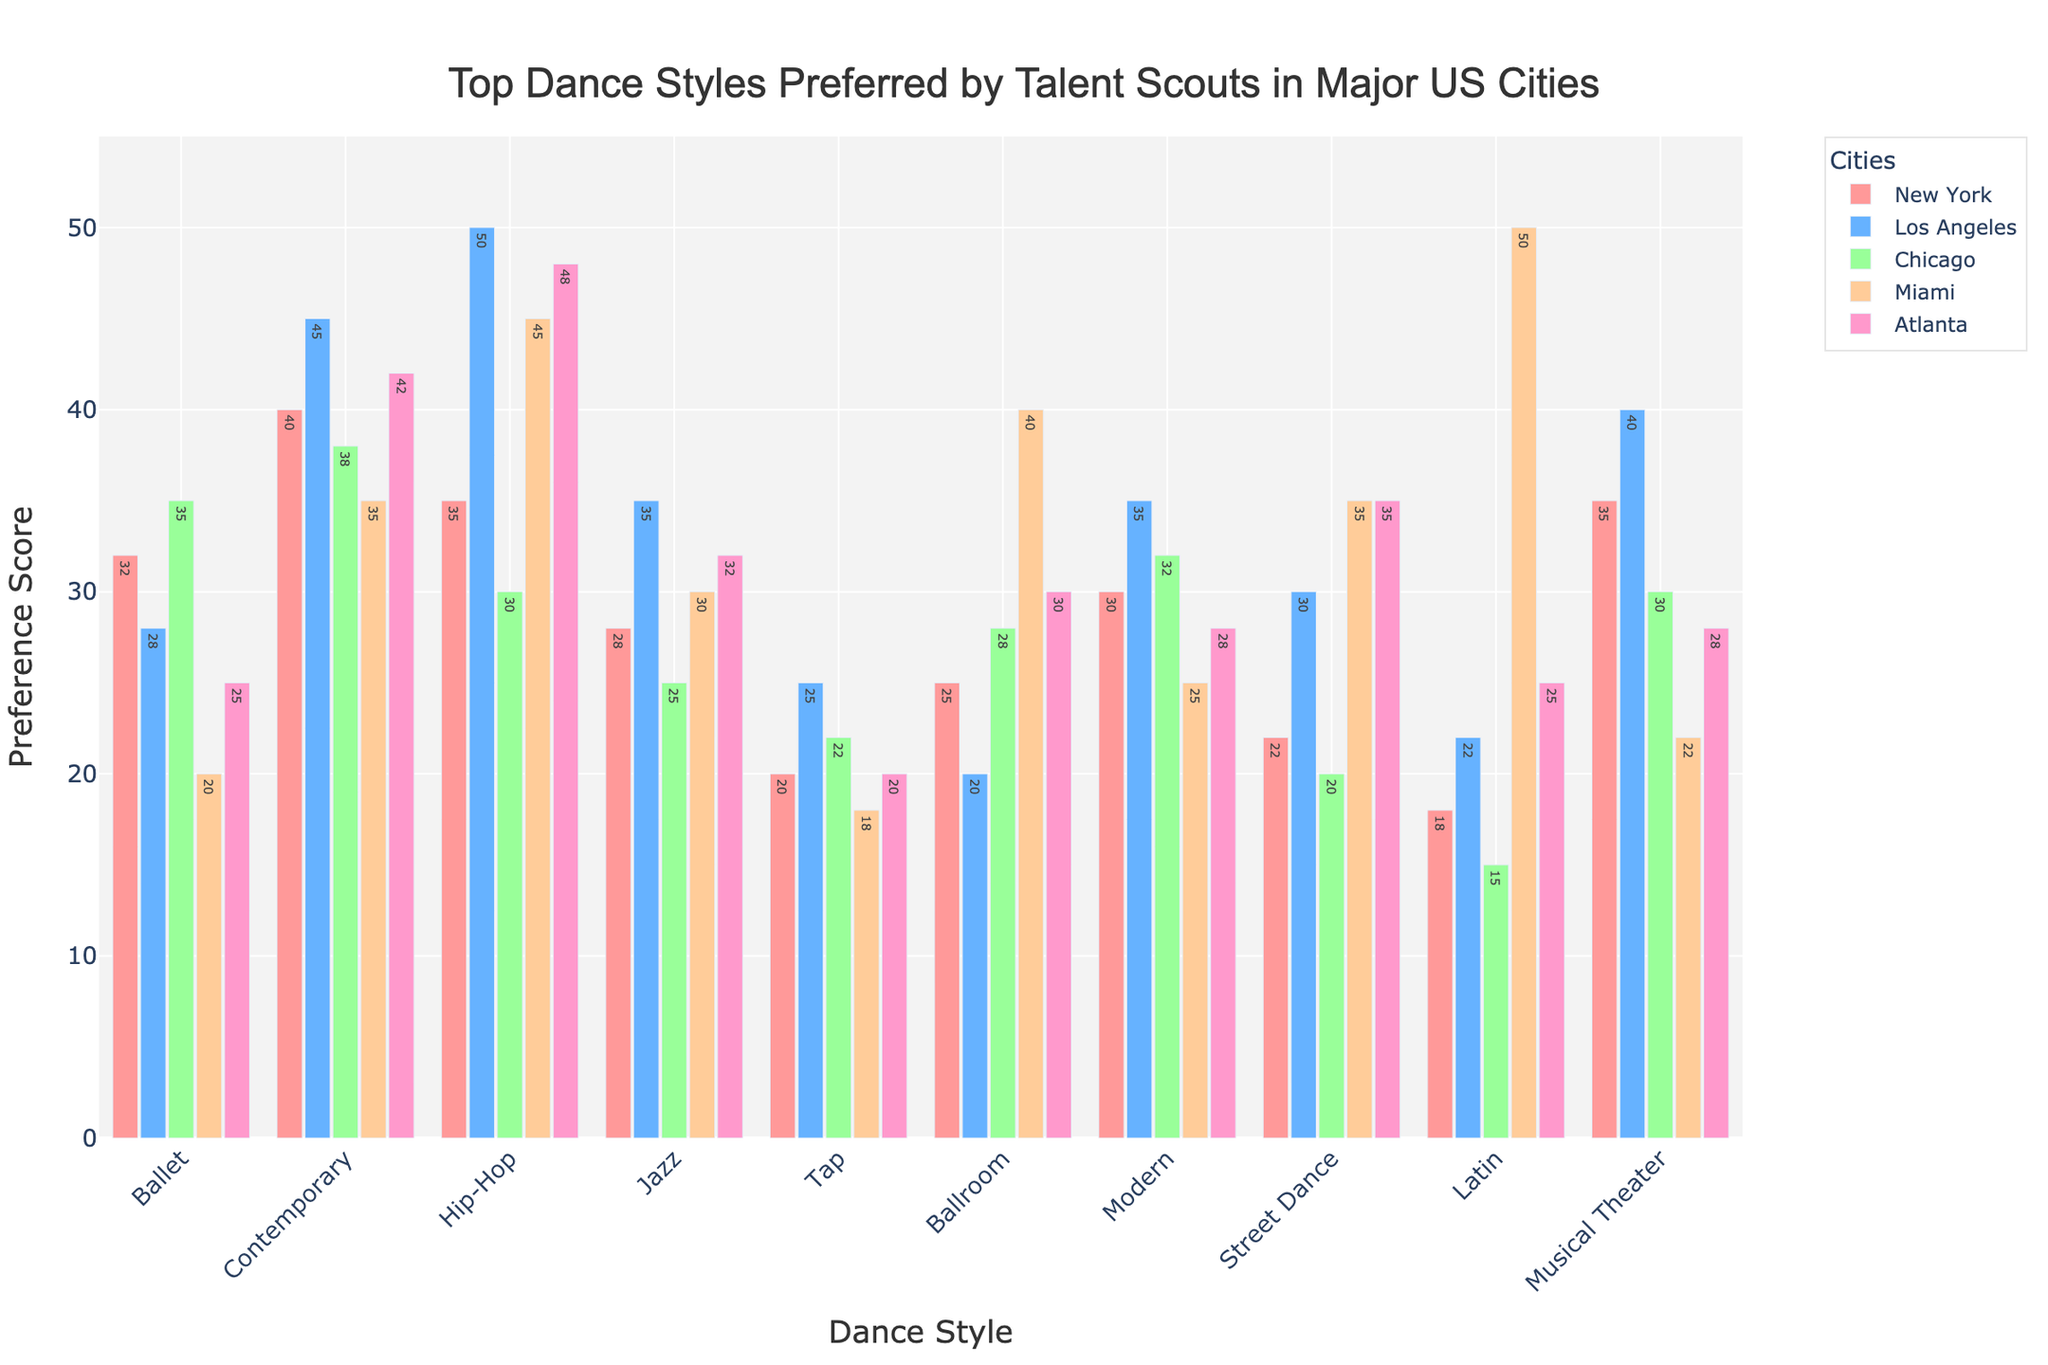What is the most preferred dance style in Los Angeles? To determine the most preferred dance style in Los Angeles, observe the bars corresponding to Los Angeles and identify the highest one. Hip-Hop has the highest bar.
Answer: Hip-Hop Which city has the highest preference score for Latin dance? Look for bars corresponding to Latin dance for each city. Compare their heights and identify the tallest bar. Miami has the highest Latin dance preference score.
Answer: Miami What is the difference in preference scores for Ballet and Hip-Hop in New York? Identify the bars for Ballet and Hip-Hop in New York. Subtract the Ballet score (32) from the Hip-Hop score (35). The difference is 35 - 32 = 3.
Answer: 3 Which dance style has the least preference in Chicago? Locate the bars for Chicago and find the shortest one. The bar for Latin dance is the shortest.
Answer: Latin Is the preference score for Ballroom higher in Miami or Los Angeles? Compare the bars for Ballroom in Miami and Los Angeles. The bar for Miami (40) is higher than for Los Angeles (20).
Answer: Miami What is the average preference score for Contemporary dance across all cities? Sum up the Contemporary scores for all cities (40 + 45 + 38 + 35 + 42 = 200). Divide by the number of cities (5). The average is 200 / 5 = 40.
Answer: 40 Which city has the second-highest preference for Street Dance? Look at the bars for Street Dance in each city. The scores are New York (22), Los Angeles (30), Chicago (20), Miami (35), and Atlanta (35). Both Miami and Atlanta have the highest score (35) but not the second. Los Angeles with a score of 30 is second-highest.
Answer: Los Angeles Do more cities prefer Hip-Hop over Jazz? By comparing the bars of Hip-Hop and Jazz across all cities, we see that the scores for Hip-Hop are New York (35), Los Angeles (50), Chicago (30), Miami (45), Atlanta (48) and for Jazz, New York (28), Los Angeles (35), Chicago (25), Miami (30), Atlanta (32). All cities have higher scores for Hip-Hop than Jazz.
Answer: Yes Which dance style has the most consistent preference scores across all cities? Consistency is indicated by similar bar heights across all cities. Contemporary (scores: 40, 45, 38, 35, 42) shows relatively less variation than others.
Answer: Contemporary What is the total preference score for Tap dance across all cities? Sum the scores for Tap dance in all cities: 20 (New York) + 25 (Los Angeles) + 22 (Chicago) + 18 (Miami) + 20 (Atlanta). The total is 105.
Answer: 105 